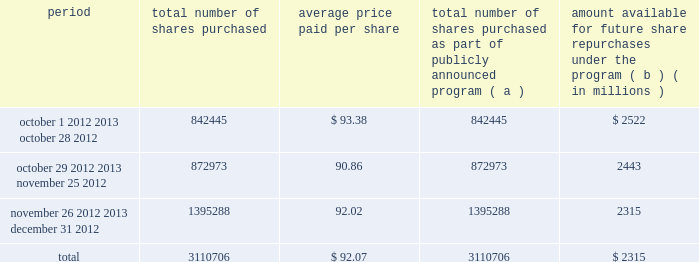Issuer purchases of equity securities the table provides information about our repurchases of common stock during the three-month period ended december 31 , 2012 .
Period total number of shares purchased average price paid per total number of shares purchased as part of publicly announced program ( a ) amount available for future share repurchases the program ( b ) ( in millions ) .
( a ) we repurchased a total of 3.1 million shares of our common stock for $ 286 million during the quarter ended december 31 , 2012 under a share repurchase program that we announced in october 2010 .
( b ) our board of directors has approved a share repurchase program for the repurchase of our common stock from time-to-time , authorizing an amount available for share repurchases of $ 6.5 billion .
Under the program , management has discretion to determine the dollar amount of shares to be repurchased and the timing of any repurchases in compliance with applicable law and regulation .
The program does not have an expiration date .
As of december 31 , 2012 , we had repurchased a total of 54.3 million shares under the program for $ 4.2 billion. .
What is the total value of repurchased shares during december 2012 , in millions? 
Computations: ((1395288 * 92.02) / 1000000)
Answer: 128.3944. 